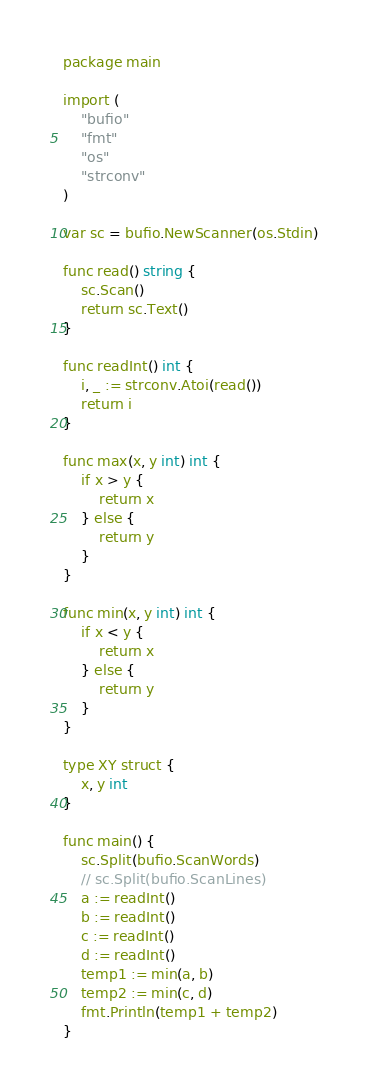Convert code to text. <code><loc_0><loc_0><loc_500><loc_500><_Go_>package main

import (
	"bufio"
	"fmt"
	"os"
	"strconv"
)

var sc = bufio.NewScanner(os.Stdin)

func read() string {
	sc.Scan()
	return sc.Text()
}

func readInt() int {
	i, _ := strconv.Atoi(read())
	return i
}

func max(x, y int) int {
	if x > y {
		return x
	} else {
		return y
	}
}

func min(x, y int) int {
	if x < y {
		return x
	} else {
		return y
	}
}

type XY struct {
	x, y int
}

func main() {
	sc.Split(bufio.ScanWords)
	// sc.Split(bufio.ScanLines)
	a := readInt()
	b := readInt()
	c := readInt()
	d := readInt()
	temp1 := min(a, b)
	temp2 := min(c, d)
	fmt.Println(temp1 + temp2)
}
</code> 